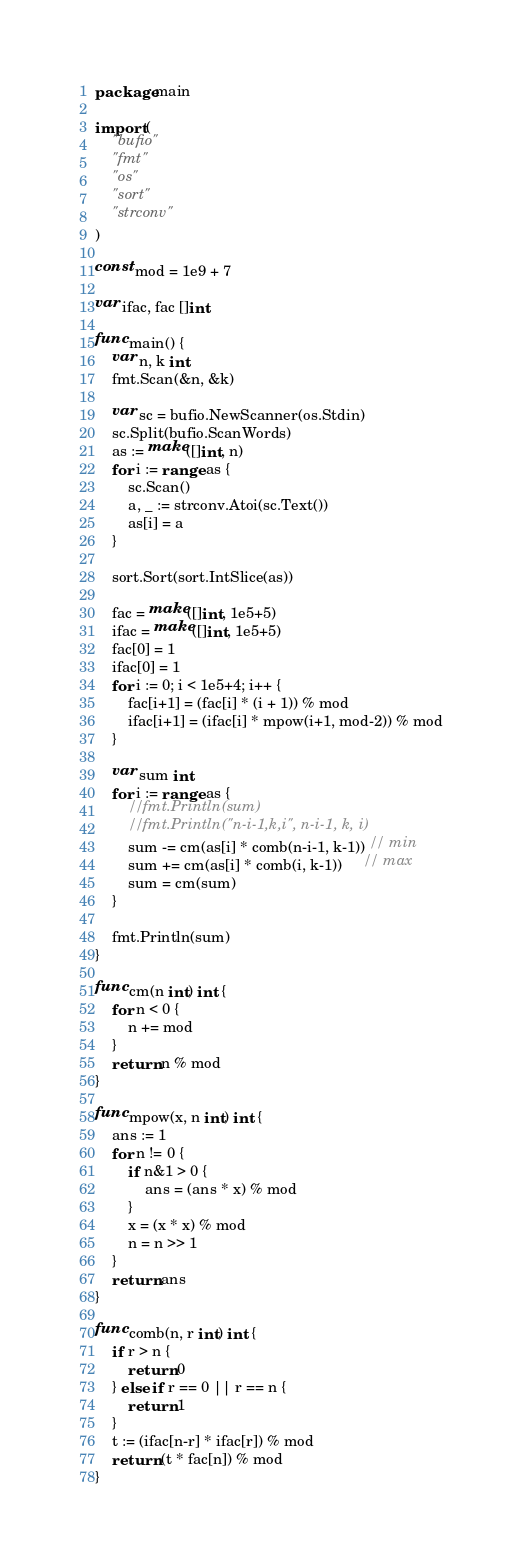<code> <loc_0><loc_0><loc_500><loc_500><_Go_>package main

import (
	"bufio"
	"fmt"
	"os"
	"sort"
	"strconv"
)

const mod = 1e9 + 7

var ifac, fac []int

func main() {
	var n, k int
	fmt.Scan(&n, &k)

	var sc = bufio.NewScanner(os.Stdin)
	sc.Split(bufio.ScanWords)
	as := make([]int, n)
	for i := range as {
		sc.Scan()
		a, _ := strconv.Atoi(sc.Text())
		as[i] = a
	}

	sort.Sort(sort.IntSlice(as))

	fac = make([]int, 1e5+5)
	ifac = make([]int, 1e5+5)
	fac[0] = 1
	ifac[0] = 1
	for i := 0; i < 1e5+4; i++ {
		fac[i+1] = (fac[i] * (i + 1)) % mod
		ifac[i+1] = (ifac[i] * mpow(i+1, mod-2)) % mod
	}

	var sum int
	for i := range as {
		//fmt.Println(sum)
		//fmt.Println("n-i-1,k,i", n-i-1, k, i)
		sum -= cm(as[i] * comb(n-i-1, k-1)) // min
		sum += cm(as[i] * comb(i, k-1))     // max
		sum = cm(sum)
	}

	fmt.Println(sum)
}

func cm(n int) int {
	for n < 0 {
		n += mod
	}
	return n % mod
}

func mpow(x, n int) int {
	ans := 1
	for n != 0 {
		if n&1 > 0 {
			ans = (ans * x) % mod
		}
		x = (x * x) % mod
		n = n >> 1
	}
	return ans
}

func comb(n, r int) int {
	if r > n {
		return 0
	} else if r == 0 || r == n {
		return 1
	}
	t := (ifac[n-r] * ifac[r]) % mod
	return (t * fac[n]) % mod
}
</code> 